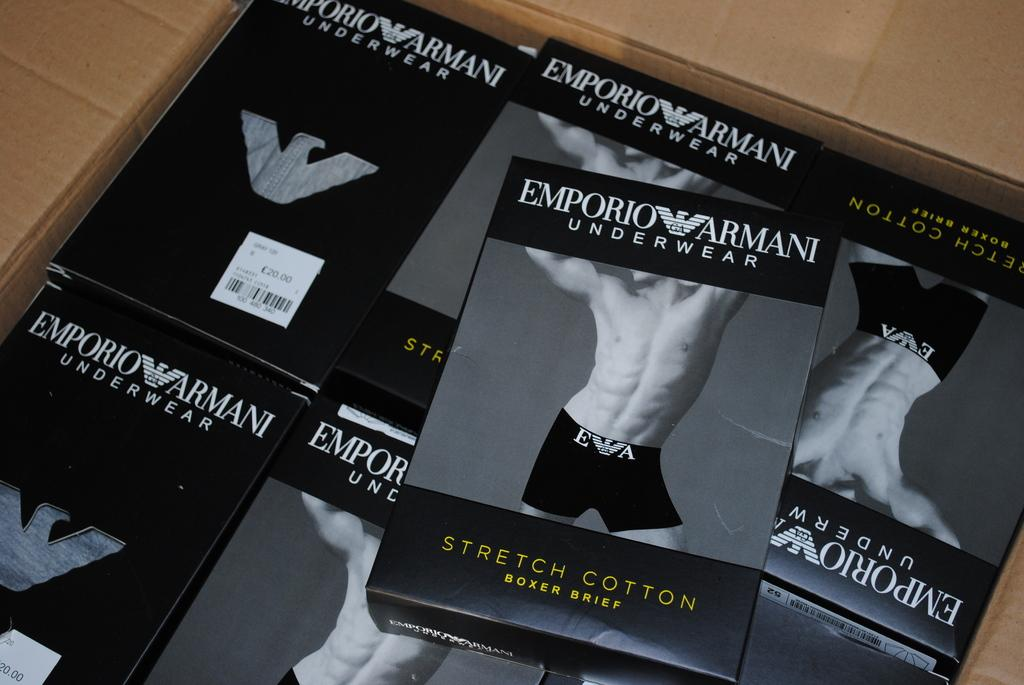<image>
Provide a brief description of the given image. A box full of small boxes that contain Armani underwear. 